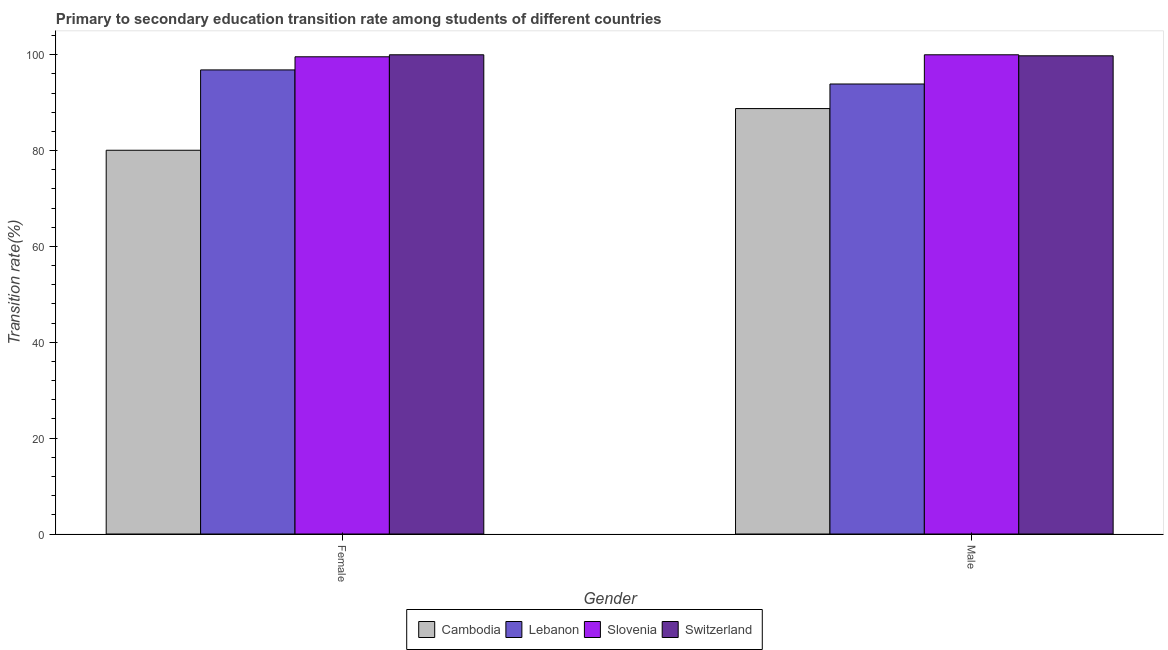How many different coloured bars are there?
Your response must be concise. 4. How many groups of bars are there?
Keep it short and to the point. 2. Are the number of bars on each tick of the X-axis equal?
Offer a very short reply. Yes. How many bars are there on the 1st tick from the left?
Offer a very short reply. 4. What is the label of the 2nd group of bars from the left?
Offer a very short reply. Male. What is the transition rate among male students in Cambodia?
Offer a very short reply. 88.78. Across all countries, what is the minimum transition rate among male students?
Provide a short and direct response. 88.78. In which country was the transition rate among female students maximum?
Your response must be concise. Switzerland. In which country was the transition rate among female students minimum?
Provide a succinct answer. Cambodia. What is the total transition rate among male students in the graph?
Your answer should be compact. 382.47. What is the difference between the transition rate among female students in Slovenia and that in Lebanon?
Your response must be concise. 2.74. What is the difference between the transition rate among female students in Slovenia and the transition rate among male students in Lebanon?
Your answer should be compact. 5.68. What is the average transition rate among female students per country?
Your answer should be very brief. 94.13. What is the difference between the transition rate among female students and transition rate among male students in Switzerland?
Your answer should be compact. 0.21. What is the ratio of the transition rate among male students in Lebanon to that in Slovenia?
Give a very brief answer. 0.94. What does the 1st bar from the left in Male represents?
Offer a very short reply. Cambodia. What does the 3rd bar from the right in Female represents?
Give a very brief answer. Lebanon. How many bars are there?
Your response must be concise. 8. Are all the bars in the graph horizontal?
Provide a short and direct response. No. How many countries are there in the graph?
Ensure brevity in your answer.  4. What is the difference between two consecutive major ticks on the Y-axis?
Keep it short and to the point. 20. Does the graph contain grids?
Your answer should be very brief. No. Where does the legend appear in the graph?
Give a very brief answer. Bottom center. What is the title of the graph?
Offer a terse response. Primary to secondary education transition rate among students of different countries. What is the label or title of the Y-axis?
Provide a succinct answer. Transition rate(%). What is the Transition rate(%) of Cambodia in Female?
Your answer should be compact. 80.08. What is the Transition rate(%) in Lebanon in Female?
Provide a succinct answer. 96.84. What is the Transition rate(%) in Slovenia in Female?
Give a very brief answer. 99.58. What is the Transition rate(%) of Cambodia in Male?
Your response must be concise. 88.78. What is the Transition rate(%) in Lebanon in Male?
Offer a terse response. 93.9. What is the Transition rate(%) in Switzerland in Male?
Provide a succinct answer. 99.79. Across all Gender, what is the maximum Transition rate(%) of Cambodia?
Offer a very short reply. 88.78. Across all Gender, what is the maximum Transition rate(%) in Lebanon?
Give a very brief answer. 96.84. Across all Gender, what is the maximum Transition rate(%) in Slovenia?
Your response must be concise. 100. Across all Gender, what is the minimum Transition rate(%) in Cambodia?
Make the answer very short. 80.08. Across all Gender, what is the minimum Transition rate(%) of Lebanon?
Ensure brevity in your answer.  93.9. Across all Gender, what is the minimum Transition rate(%) of Slovenia?
Make the answer very short. 99.58. Across all Gender, what is the minimum Transition rate(%) in Switzerland?
Your answer should be very brief. 99.79. What is the total Transition rate(%) in Cambodia in the graph?
Keep it short and to the point. 168.85. What is the total Transition rate(%) in Lebanon in the graph?
Provide a short and direct response. 190.75. What is the total Transition rate(%) of Slovenia in the graph?
Keep it short and to the point. 199.58. What is the total Transition rate(%) of Switzerland in the graph?
Offer a terse response. 199.79. What is the difference between the Transition rate(%) of Cambodia in Female and that in Male?
Provide a succinct answer. -8.7. What is the difference between the Transition rate(%) in Lebanon in Female and that in Male?
Provide a short and direct response. 2.94. What is the difference between the Transition rate(%) in Slovenia in Female and that in Male?
Your answer should be compact. -0.42. What is the difference between the Transition rate(%) in Switzerland in Female and that in Male?
Ensure brevity in your answer.  0.21. What is the difference between the Transition rate(%) in Cambodia in Female and the Transition rate(%) in Lebanon in Male?
Give a very brief answer. -13.83. What is the difference between the Transition rate(%) in Cambodia in Female and the Transition rate(%) in Slovenia in Male?
Provide a succinct answer. -19.92. What is the difference between the Transition rate(%) of Cambodia in Female and the Transition rate(%) of Switzerland in Male?
Your response must be concise. -19.71. What is the difference between the Transition rate(%) in Lebanon in Female and the Transition rate(%) in Slovenia in Male?
Offer a terse response. -3.16. What is the difference between the Transition rate(%) in Lebanon in Female and the Transition rate(%) in Switzerland in Male?
Your answer should be very brief. -2.94. What is the difference between the Transition rate(%) of Slovenia in Female and the Transition rate(%) of Switzerland in Male?
Your answer should be compact. -0.2. What is the average Transition rate(%) of Cambodia per Gender?
Your answer should be compact. 84.43. What is the average Transition rate(%) in Lebanon per Gender?
Your answer should be very brief. 95.37. What is the average Transition rate(%) in Slovenia per Gender?
Ensure brevity in your answer.  99.79. What is the average Transition rate(%) of Switzerland per Gender?
Your answer should be compact. 99.89. What is the difference between the Transition rate(%) in Cambodia and Transition rate(%) in Lebanon in Female?
Offer a very short reply. -16.77. What is the difference between the Transition rate(%) in Cambodia and Transition rate(%) in Slovenia in Female?
Make the answer very short. -19.5. What is the difference between the Transition rate(%) in Cambodia and Transition rate(%) in Switzerland in Female?
Keep it short and to the point. -19.92. What is the difference between the Transition rate(%) in Lebanon and Transition rate(%) in Slovenia in Female?
Your answer should be compact. -2.74. What is the difference between the Transition rate(%) in Lebanon and Transition rate(%) in Switzerland in Female?
Your response must be concise. -3.16. What is the difference between the Transition rate(%) in Slovenia and Transition rate(%) in Switzerland in Female?
Provide a short and direct response. -0.42. What is the difference between the Transition rate(%) of Cambodia and Transition rate(%) of Lebanon in Male?
Offer a very short reply. -5.13. What is the difference between the Transition rate(%) in Cambodia and Transition rate(%) in Slovenia in Male?
Keep it short and to the point. -11.22. What is the difference between the Transition rate(%) in Cambodia and Transition rate(%) in Switzerland in Male?
Keep it short and to the point. -11.01. What is the difference between the Transition rate(%) in Lebanon and Transition rate(%) in Slovenia in Male?
Provide a succinct answer. -6.1. What is the difference between the Transition rate(%) of Lebanon and Transition rate(%) of Switzerland in Male?
Provide a succinct answer. -5.88. What is the difference between the Transition rate(%) in Slovenia and Transition rate(%) in Switzerland in Male?
Offer a very short reply. 0.21. What is the ratio of the Transition rate(%) of Cambodia in Female to that in Male?
Offer a very short reply. 0.9. What is the ratio of the Transition rate(%) of Lebanon in Female to that in Male?
Your answer should be compact. 1.03. What is the difference between the highest and the second highest Transition rate(%) of Cambodia?
Provide a short and direct response. 8.7. What is the difference between the highest and the second highest Transition rate(%) in Lebanon?
Keep it short and to the point. 2.94. What is the difference between the highest and the second highest Transition rate(%) in Slovenia?
Your answer should be very brief. 0.42. What is the difference between the highest and the second highest Transition rate(%) of Switzerland?
Your answer should be very brief. 0.21. What is the difference between the highest and the lowest Transition rate(%) in Cambodia?
Offer a very short reply. 8.7. What is the difference between the highest and the lowest Transition rate(%) in Lebanon?
Offer a very short reply. 2.94. What is the difference between the highest and the lowest Transition rate(%) of Slovenia?
Keep it short and to the point. 0.42. What is the difference between the highest and the lowest Transition rate(%) of Switzerland?
Your response must be concise. 0.21. 